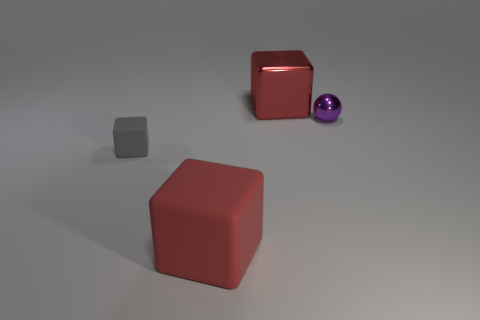Can you describe the lighting of the scene? The lighting in the scene appears soft and diffused, with a somewhat overhead direction, as indicated by the gentle shadows beneath the objects. The lack of strong highlights or dark shadows suggests that the source of light may be somewhat large or there might be several light sources, contributing to the soft lighting environment. 